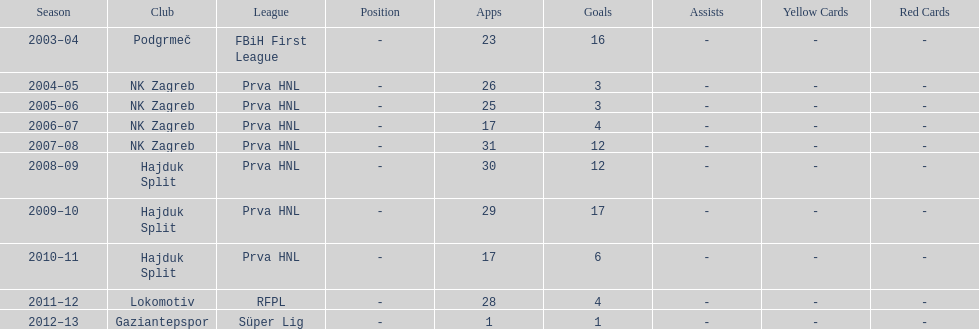What is the highest number of goals scored by senijad ibri&#269;i&#263; in a season? 35. Could you help me parse every detail presented in this table? {'header': ['Season', 'Club', 'League', 'Position', 'Apps', 'Goals', 'Assists', 'Yellow Cards', 'Red Cards'], 'rows': [['2003–04', 'Podgrmeč', 'FBiH First League', '-', '23', '16', '-', '-', '-'], ['2004–05', 'NK Zagreb', 'Prva HNL', '-', '26', '3', '-', '-', '-'], ['2005–06', 'NK Zagreb', 'Prva HNL', '-', '25', '3', '-', '-', '-'], ['2006–07', 'NK Zagreb', 'Prva HNL', '-', '17', '4', '-', '-', '-'], ['2007–08', 'NK Zagreb', 'Prva HNL', '-', '31', '12', '-', '-', '-'], ['2008–09', 'Hajduk Split', 'Prva HNL', '-', '30', '12', '-', '-', '-'], ['2009–10', 'Hajduk Split', 'Prva HNL', '-', '29', '17', '-', '-', '-'], ['2010–11', 'Hajduk Split', 'Prva HNL', '-', '17', '6', '-', '-', '-'], ['2011–12', 'Lokomotiv', 'RFPL', '-', '28', '4', '-', '-', '-'], ['2012–13', 'Gaziantepspor', 'Süper Lig', '-', '1', '1', '-', '-', '-']]} 